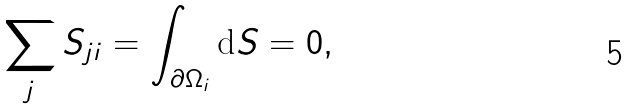Convert formula to latex. <formula><loc_0><loc_0><loc_500><loc_500>\sum _ { j } S _ { j i } = \int _ { \partial \Omega _ { i } } \text {d} S = 0 ,</formula> 